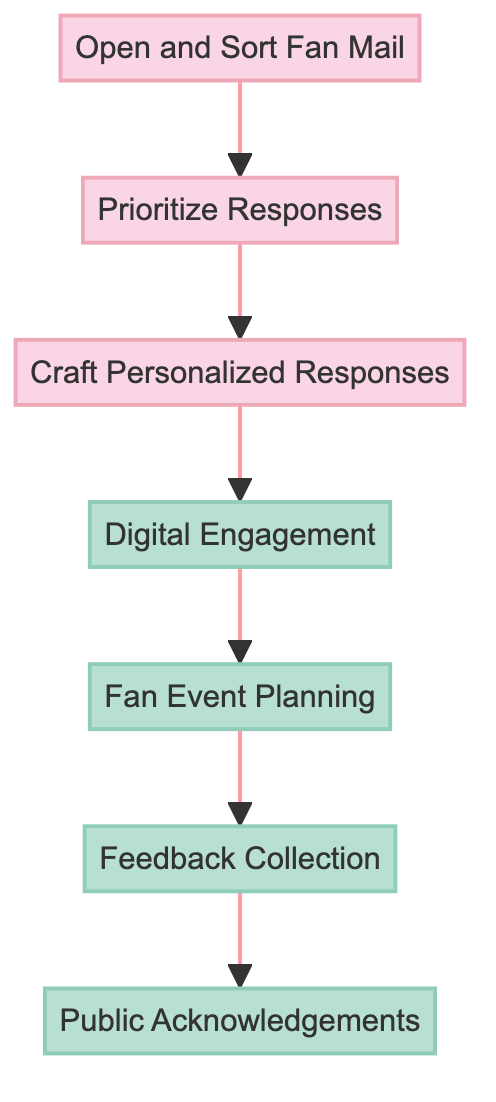What is the first step in managing fan interactions? The first step is "Open and Sort Fan Mail," which indicates that receiving and classifying fan mail is the initial action required to manage interactions.
Answer: Open and Sort Fan Mail How many steps are there in the flowchart? Counting each step from the diagram reveals there are seven distinct steps in the process of managing fan interactions.
Answer: 7 Which step involves responding to fans on social media? The step dedicated to engaging with fans on social media is "Digital Engagement," which focuses on responding to comments and posting updates.
Answer: Digital Engagement What precedes "Craft Personalized Responses"? "Prioritize Responses" is the step that comes before "Craft Personalized Responses," indicating that identifying urgent messages is necessary before drafting replies.
Answer: Prioritize Responses What type of feedback is gathered after "Fan Event Planning"? The type of feedback gathered after "Fan Event Planning" is collected through "Feedback Collection," which utilizes surveys and social media analytics from fans.
Answer: Feedback Collection What does "Public Acknowledgements" represent in the process? "Public Acknowledgements" represents the final step where special fan stories and contributions are recognized, fostering community engagement among fans.
Answer: Public Acknowledgements Which steps highlight the importance of interaction? The highlighted steps representing significant interactions with fans are "Digital Engagement," "Fan Event Planning," "Feedback Collection," and "Public Acknowledgements," emphasizing the flow of engaging activities.
Answer: Digital Engagement, Fan Event Planning, Feedback Collection, Public Acknowledgements How does the flowchart indicate the relationship between steps? The flowchart indicates the relationship between steps through directional arrows connecting each node, showing the sequence of actions required to manage fan interactions effectively.
Answer: Directional arrows 